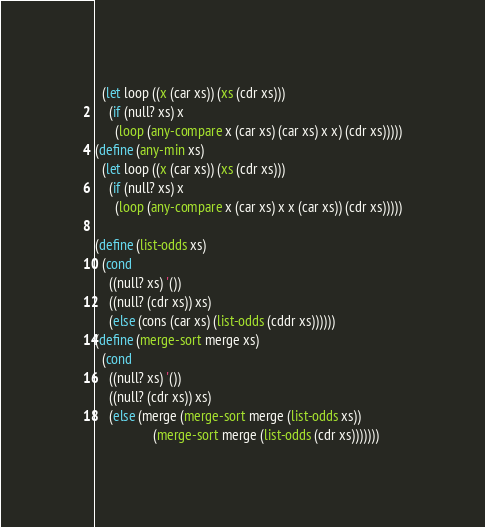<code> <loc_0><loc_0><loc_500><loc_500><_Scheme_>  (let loop ((x (car xs)) (xs (cdr xs)))
    (if (null? xs) x
      (loop (any-compare x (car xs) (car xs) x x) (cdr xs)))))
(define (any-min xs)
  (let loop ((x (car xs)) (xs (cdr xs)))
    (if (null? xs) x
      (loop (any-compare x (car xs) x x (car xs)) (cdr xs)))))

(define (list-odds xs)
  (cond
    ((null? xs) '())
    ((null? (cdr xs)) xs)
    (else (cons (car xs) (list-odds (cddr xs))))))
(define (merge-sort merge xs)
  (cond
    ((null? xs) '())
    ((null? (cdr xs)) xs)
    (else (merge (merge-sort merge (list-odds xs))
                 (merge-sort merge (list-odds (cdr xs)))))))
</code> 